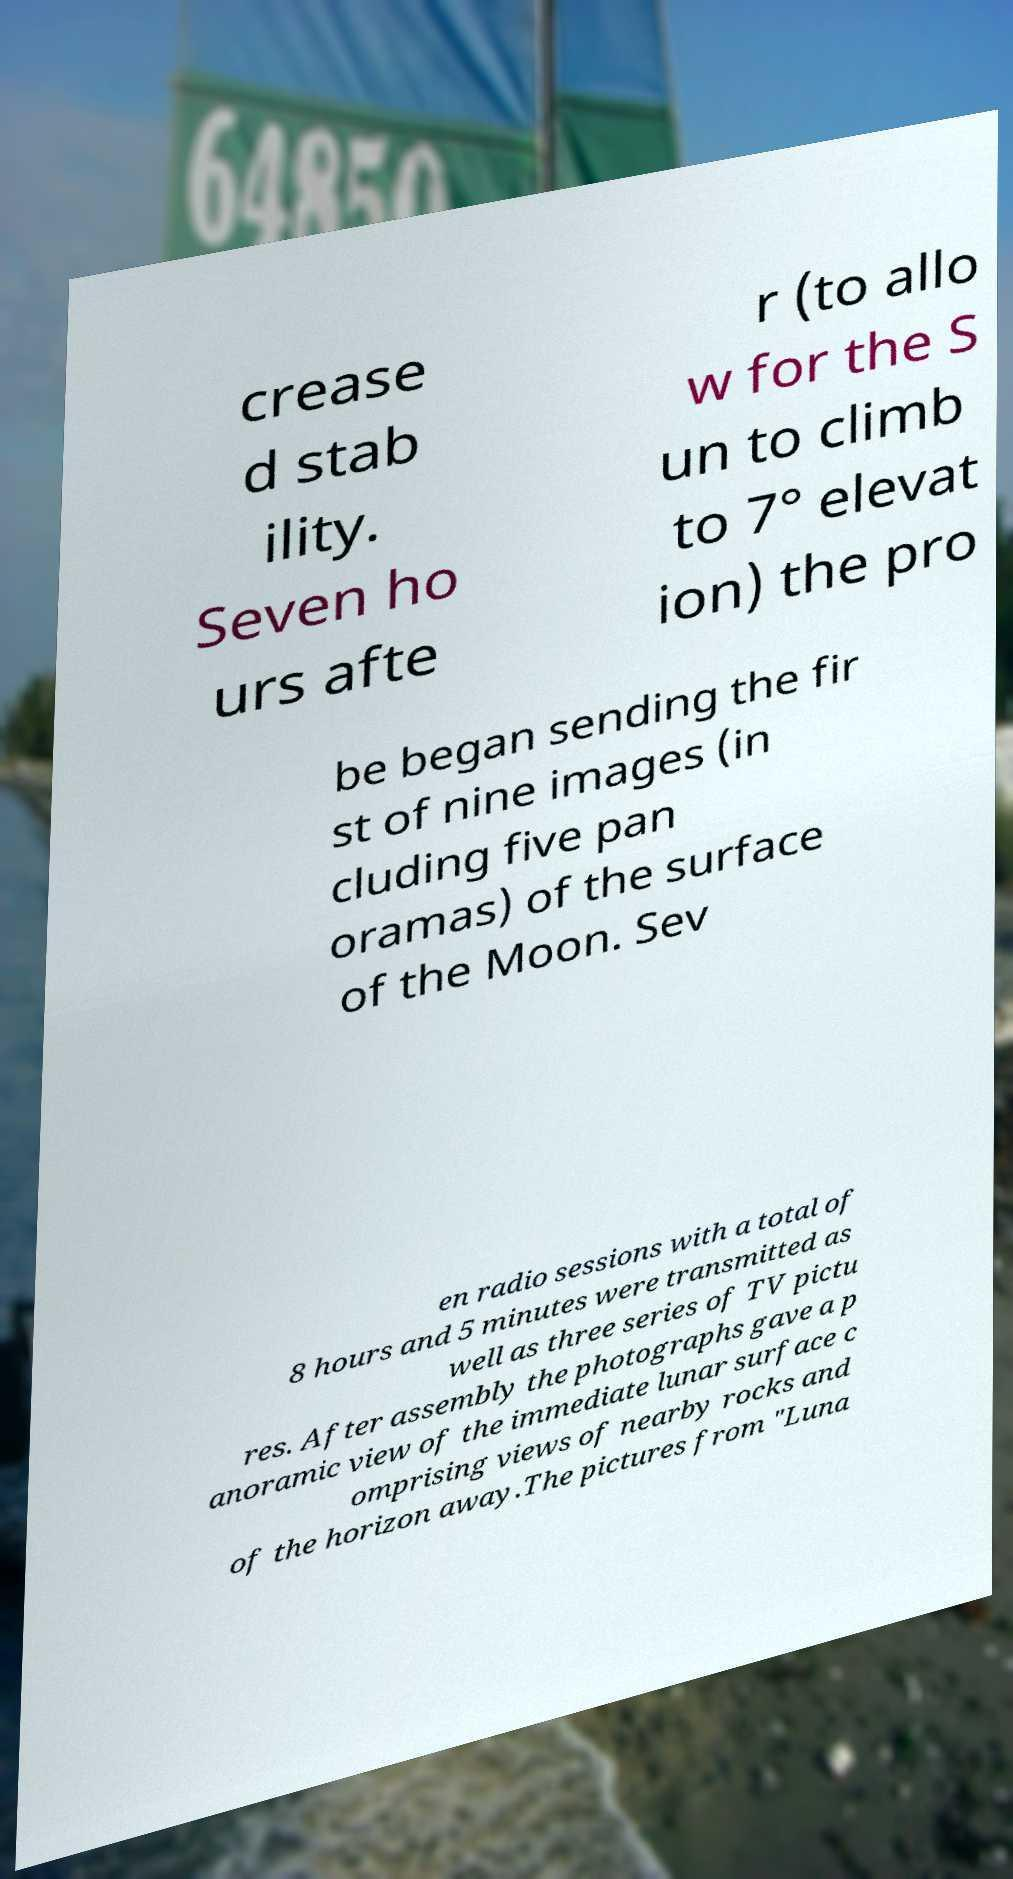What messages or text are displayed in this image? I need them in a readable, typed format. crease d stab ility. Seven ho urs afte r (to allo w for the S un to climb to 7° elevat ion) the pro be began sending the fir st of nine images (in cluding five pan oramas) of the surface of the Moon. Sev en radio sessions with a total of 8 hours and 5 minutes were transmitted as well as three series of TV pictu res. After assembly the photographs gave a p anoramic view of the immediate lunar surface c omprising views of nearby rocks and of the horizon away.The pictures from "Luna 